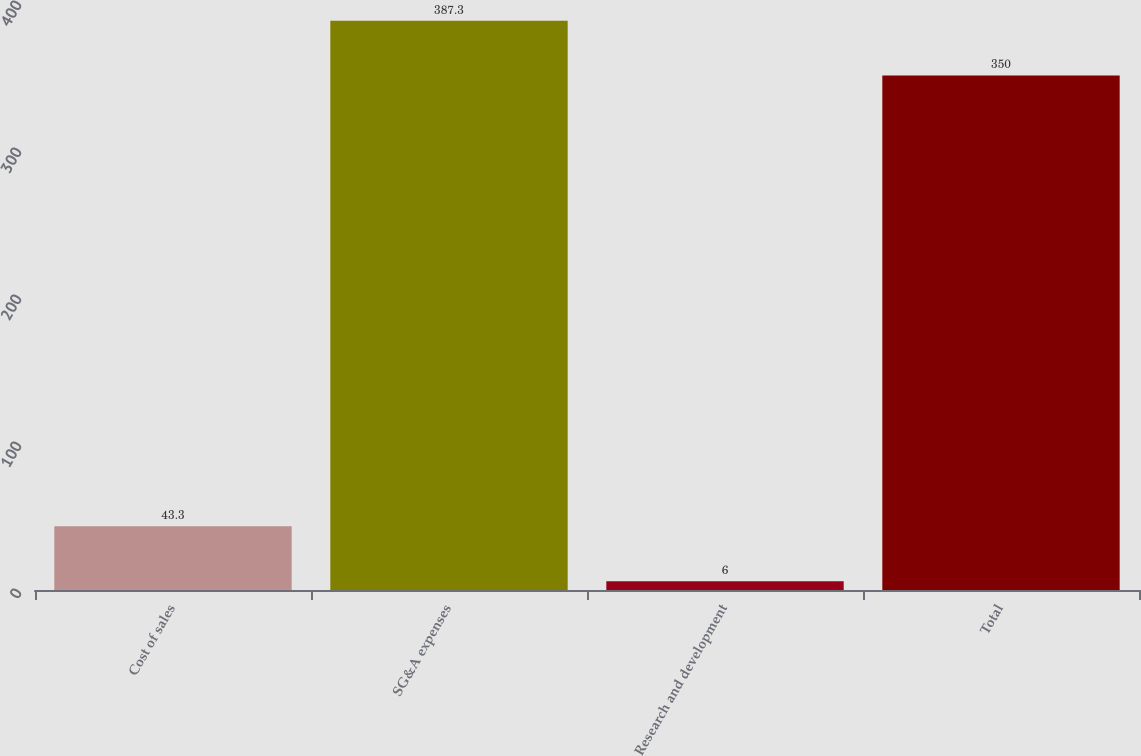Convert chart to OTSL. <chart><loc_0><loc_0><loc_500><loc_500><bar_chart><fcel>Cost of sales<fcel>SG&A expenses<fcel>Research and development<fcel>Total<nl><fcel>43.3<fcel>387.3<fcel>6<fcel>350<nl></chart> 